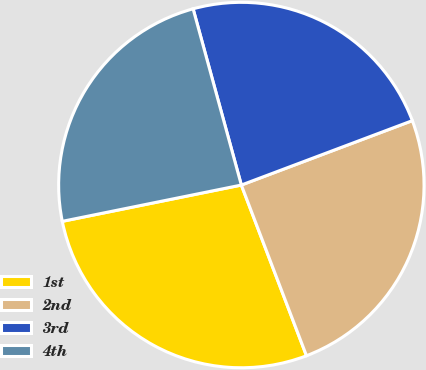<chart> <loc_0><loc_0><loc_500><loc_500><pie_chart><fcel>1st<fcel>2nd<fcel>3rd<fcel>4th<nl><fcel>27.62%<fcel>24.93%<fcel>23.52%<fcel>23.93%<nl></chart> 